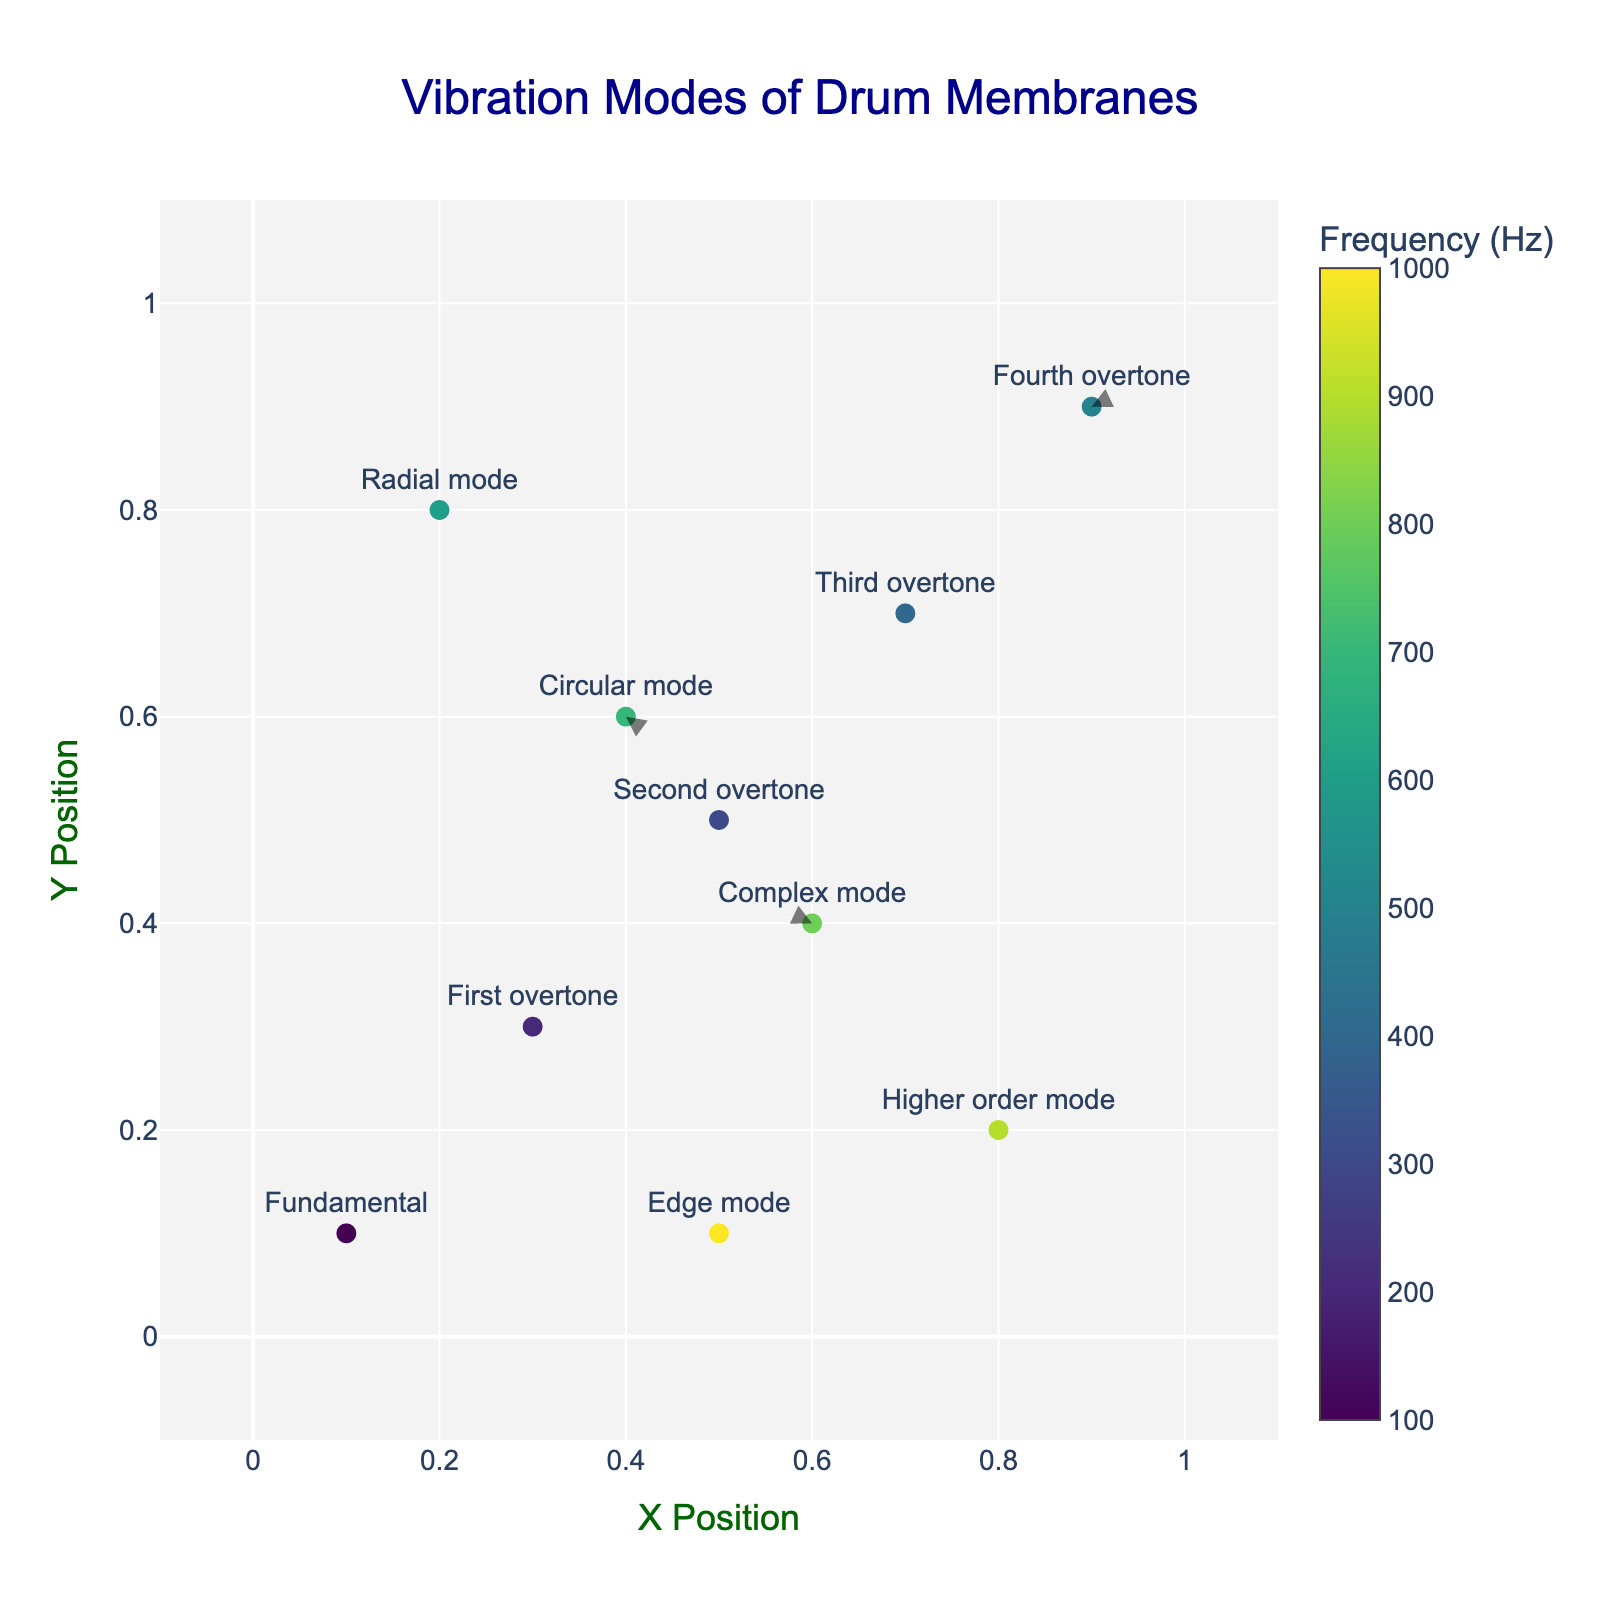What's the title of the plot? The title is displayed at the top center of the figure. It clearly describes what the plot represents.
Answer: Vibration Modes of Drum Membranes What is the x-axis labeled as? The x-axis label is found below the horizontal axis, describing the data represented on the horizontal scale.
Answer: X Position Which mode has the highest frequency? The color of each marker denotes the frequency, and the color bar on the right side provides the frequency scale. The hover text can also give specific information. The highest frequency corresponds to the darkest color.
Answer: Edge mode How many data points are present in the plot? By counting the number of markers on the plot, we determine how many data points are included.
Answer: 10 What range do the x and y coordinates cover? The x and y axes span from slightly below 0 to slightly above 1, as shown by the axis limits.
Answer: -0.1 to 1.1 What is the direction of the vector at (0.7, 0.7)? Look at the arrow originating from (0.7, 0.7). The arrow points to the direction and length indicated by u and v values: (-0.06, -0.04).
Answer: Left and slightly downwards Which mode lies at the coordinates (0.4, 0.6)? Refer to the markers on the plot for their hover text or text labels. The mode at (0.4, 0.6) is also indicated.
Answer: Circular mode Which two modes have the x-component of their vectors with opposite signs at their origin points (positive and negative signs)? Compare the u values at each point. Positive u values (>0) denote one sign, and negative u values (<0) denote the opposite sign. One of such pairs can be identified from the data points. For example, (0.1, 0.1) has u=0.05 and (0.3, 0.3) has u=-0.04.
Answer: Fundamental and First overtone What is the average frequency of the Fundamental and Second overtone modes? Add the frequencies of the Fundamental mode (100 Hz) and the Second overtone mode (300 Hz), then divide by 2 to find the average.
Answer: (100 + 300) / 2 = 200 Hz Which mode's vector points most upwards? Compare the v components of the vectors. The component with the highest positive value indicates the vector pointing most upwards.
Answer: First overtone (v=0.06) 